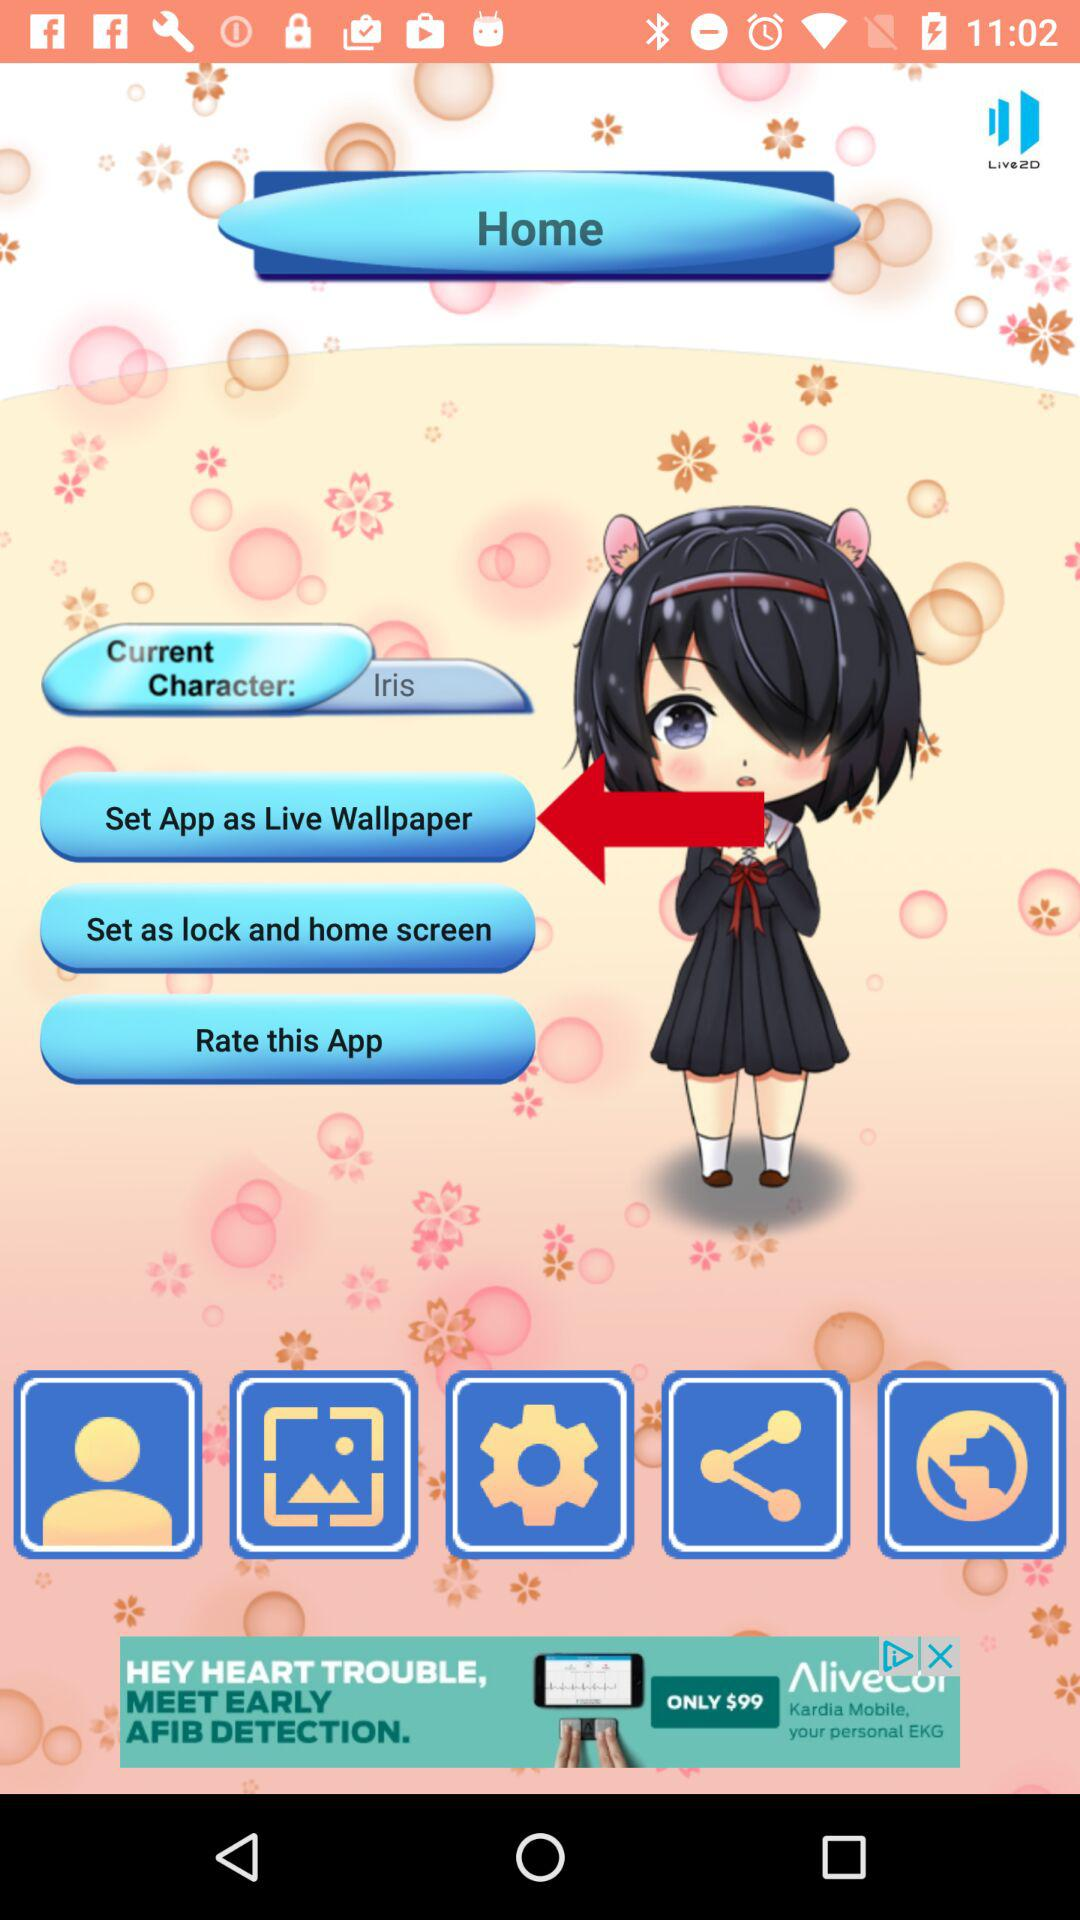What's the current character's name? The name is Iris. 